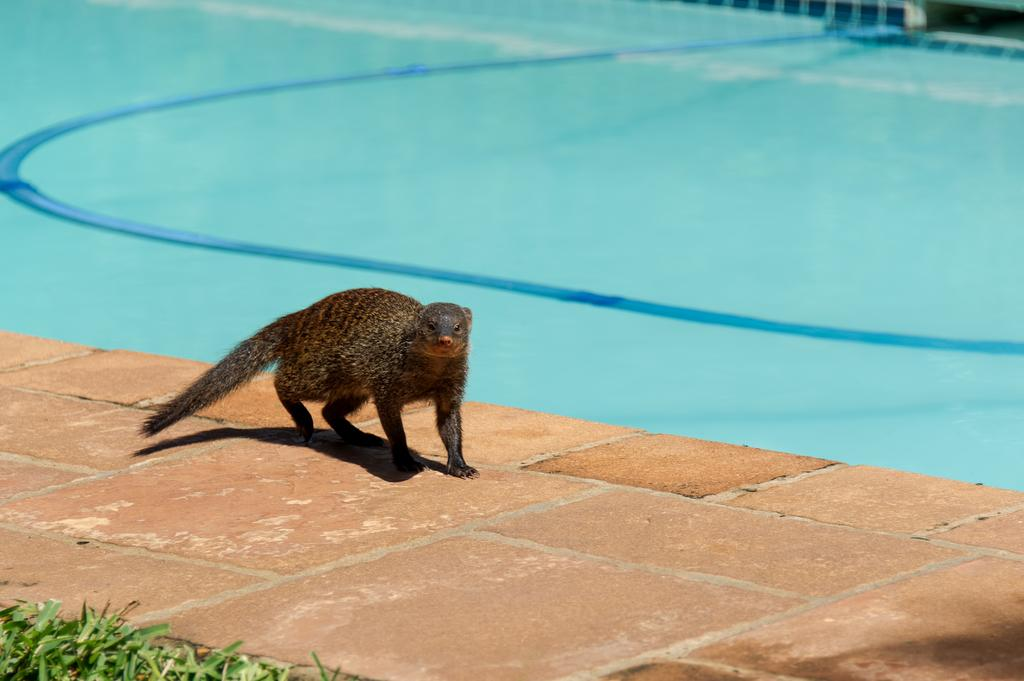What type of vegetation can be seen in the image? There is grass in the image. What is located on the ground in the image? There is an animal on the ground in the image. What can be seen in the distance in the image? There is water visible in the background of the image. Can you see any cobwebs in the image? There is no mention of cobwebs in the provided facts, so we cannot determine if any are present in the image. 